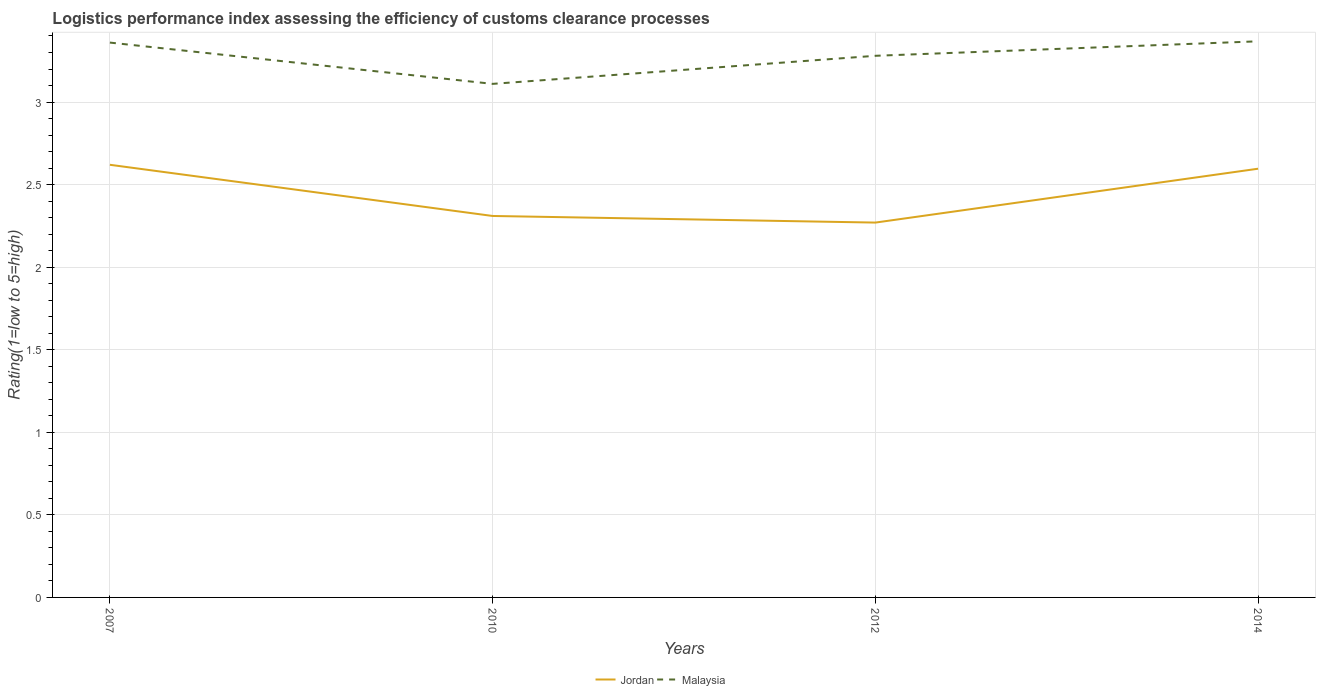Does the line corresponding to Malaysia intersect with the line corresponding to Jordan?
Provide a short and direct response. No. Across all years, what is the maximum Logistic performance index in Malaysia?
Provide a succinct answer. 3.11. What is the total Logistic performance index in Malaysia in the graph?
Ensure brevity in your answer.  -0.09. What is the difference between the highest and the second highest Logistic performance index in Jordan?
Ensure brevity in your answer.  0.35. How many lines are there?
Give a very brief answer. 2. How many years are there in the graph?
Give a very brief answer. 4. Does the graph contain grids?
Make the answer very short. Yes. How many legend labels are there?
Provide a short and direct response. 2. What is the title of the graph?
Make the answer very short. Logistics performance index assessing the efficiency of customs clearance processes. Does "Vietnam" appear as one of the legend labels in the graph?
Make the answer very short. No. What is the label or title of the Y-axis?
Your answer should be very brief. Rating(1=low to 5=high). What is the Rating(1=low to 5=high) of Jordan in 2007?
Provide a short and direct response. 2.62. What is the Rating(1=low to 5=high) in Malaysia in 2007?
Provide a short and direct response. 3.36. What is the Rating(1=low to 5=high) in Jordan in 2010?
Keep it short and to the point. 2.31. What is the Rating(1=low to 5=high) in Malaysia in 2010?
Provide a succinct answer. 3.11. What is the Rating(1=low to 5=high) in Jordan in 2012?
Your answer should be compact. 2.27. What is the Rating(1=low to 5=high) in Malaysia in 2012?
Give a very brief answer. 3.28. What is the Rating(1=low to 5=high) in Jordan in 2014?
Provide a short and direct response. 2.6. What is the Rating(1=low to 5=high) of Malaysia in 2014?
Keep it short and to the point. 3.37. Across all years, what is the maximum Rating(1=low to 5=high) in Jordan?
Offer a terse response. 2.62. Across all years, what is the maximum Rating(1=low to 5=high) in Malaysia?
Your answer should be compact. 3.37. Across all years, what is the minimum Rating(1=low to 5=high) of Jordan?
Keep it short and to the point. 2.27. Across all years, what is the minimum Rating(1=low to 5=high) in Malaysia?
Provide a short and direct response. 3.11. What is the total Rating(1=low to 5=high) of Jordan in the graph?
Provide a short and direct response. 9.8. What is the total Rating(1=low to 5=high) in Malaysia in the graph?
Provide a short and direct response. 13.12. What is the difference between the Rating(1=low to 5=high) in Jordan in 2007 and that in 2010?
Provide a succinct answer. 0.31. What is the difference between the Rating(1=low to 5=high) of Malaysia in 2007 and that in 2010?
Provide a short and direct response. 0.25. What is the difference between the Rating(1=low to 5=high) in Jordan in 2007 and that in 2012?
Offer a terse response. 0.35. What is the difference between the Rating(1=low to 5=high) in Jordan in 2007 and that in 2014?
Give a very brief answer. 0.02. What is the difference between the Rating(1=low to 5=high) in Malaysia in 2007 and that in 2014?
Your response must be concise. -0.01. What is the difference between the Rating(1=low to 5=high) of Jordan in 2010 and that in 2012?
Provide a short and direct response. 0.04. What is the difference between the Rating(1=low to 5=high) in Malaysia in 2010 and that in 2012?
Your answer should be very brief. -0.17. What is the difference between the Rating(1=low to 5=high) of Jordan in 2010 and that in 2014?
Your answer should be compact. -0.29. What is the difference between the Rating(1=low to 5=high) in Malaysia in 2010 and that in 2014?
Offer a very short reply. -0.26. What is the difference between the Rating(1=low to 5=high) in Jordan in 2012 and that in 2014?
Provide a succinct answer. -0.33. What is the difference between the Rating(1=low to 5=high) of Malaysia in 2012 and that in 2014?
Offer a very short reply. -0.09. What is the difference between the Rating(1=low to 5=high) in Jordan in 2007 and the Rating(1=low to 5=high) in Malaysia in 2010?
Your answer should be compact. -0.49. What is the difference between the Rating(1=low to 5=high) of Jordan in 2007 and the Rating(1=low to 5=high) of Malaysia in 2012?
Your answer should be very brief. -0.66. What is the difference between the Rating(1=low to 5=high) in Jordan in 2007 and the Rating(1=low to 5=high) in Malaysia in 2014?
Make the answer very short. -0.75. What is the difference between the Rating(1=low to 5=high) of Jordan in 2010 and the Rating(1=low to 5=high) of Malaysia in 2012?
Make the answer very short. -0.97. What is the difference between the Rating(1=low to 5=high) in Jordan in 2010 and the Rating(1=low to 5=high) in Malaysia in 2014?
Ensure brevity in your answer.  -1.06. What is the difference between the Rating(1=low to 5=high) of Jordan in 2012 and the Rating(1=low to 5=high) of Malaysia in 2014?
Make the answer very short. -1.1. What is the average Rating(1=low to 5=high) in Jordan per year?
Offer a terse response. 2.45. What is the average Rating(1=low to 5=high) of Malaysia per year?
Ensure brevity in your answer.  3.28. In the year 2007, what is the difference between the Rating(1=low to 5=high) of Jordan and Rating(1=low to 5=high) of Malaysia?
Offer a very short reply. -0.74. In the year 2012, what is the difference between the Rating(1=low to 5=high) in Jordan and Rating(1=low to 5=high) in Malaysia?
Keep it short and to the point. -1.01. In the year 2014, what is the difference between the Rating(1=low to 5=high) in Jordan and Rating(1=low to 5=high) in Malaysia?
Keep it short and to the point. -0.77. What is the ratio of the Rating(1=low to 5=high) of Jordan in 2007 to that in 2010?
Your response must be concise. 1.13. What is the ratio of the Rating(1=low to 5=high) in Malaysia in 2007 to that in 2010?
Offer a terse response. 1.08. What is the ratio of the Rating(1=low to 5=high) of Jordan in 2007 to that in 2012?
Provide a short and direct response. 1.15. What is the ratio of the Rating(1=low to 5=high) of Malaysia in 2007 to that in 2012?
Provide a short and direct response. 1.02. What is the ratio of the Rating(1=low to 5=high) of Jordan in 2007 to that in 2014?
Keep it short and to the point. 1.01. What is the ratio of the Rating(1=low to 5=high) of Jordan in 2010 to that in 2012?
Provide a short and direct response. 1.02. What is the ratio of the Rating(1=low to 5=high) in Malaysia in 2010 to that in 2012?
Your answer should be compact. 0.95. What is the ratio of the Rating(1=low to 5=high) in Jordan in 2010 to that in 2014?
Make the answer very short. 0.89. What is the ratio of the Rating(1=low to 5=high) in Malaysia in 2010 to that in 2014?
Your answer should be very brief. 0.92. What is the ratio of the Rating(1=low to 5=high) of Jordan in 2012 to that in 2014?
Your response must be concise. 0.87. What is the ratio of the Rating(1=low to 5=high) of Malaysia in 2012 to that in 2014?
Offer a terse response. 0.97. What is the difference between the highest and the second highest Rating(1=low to 5=high) in Jordan?
Offer a very short reply. 0.02. What is the difference between the highest and the second highest Rating(1=low to 5=high) in Malaysia?
Make the answer very short. 0.01. What is the difference between the highest and the lowest Rating(1=low to 5=high) in Jordan?
Your response must be concise. 0.35. What is the difference between the highest and the lowest Rating(1=low to 5=high) of Malaysia?
Make the answer very short. 0.26. 